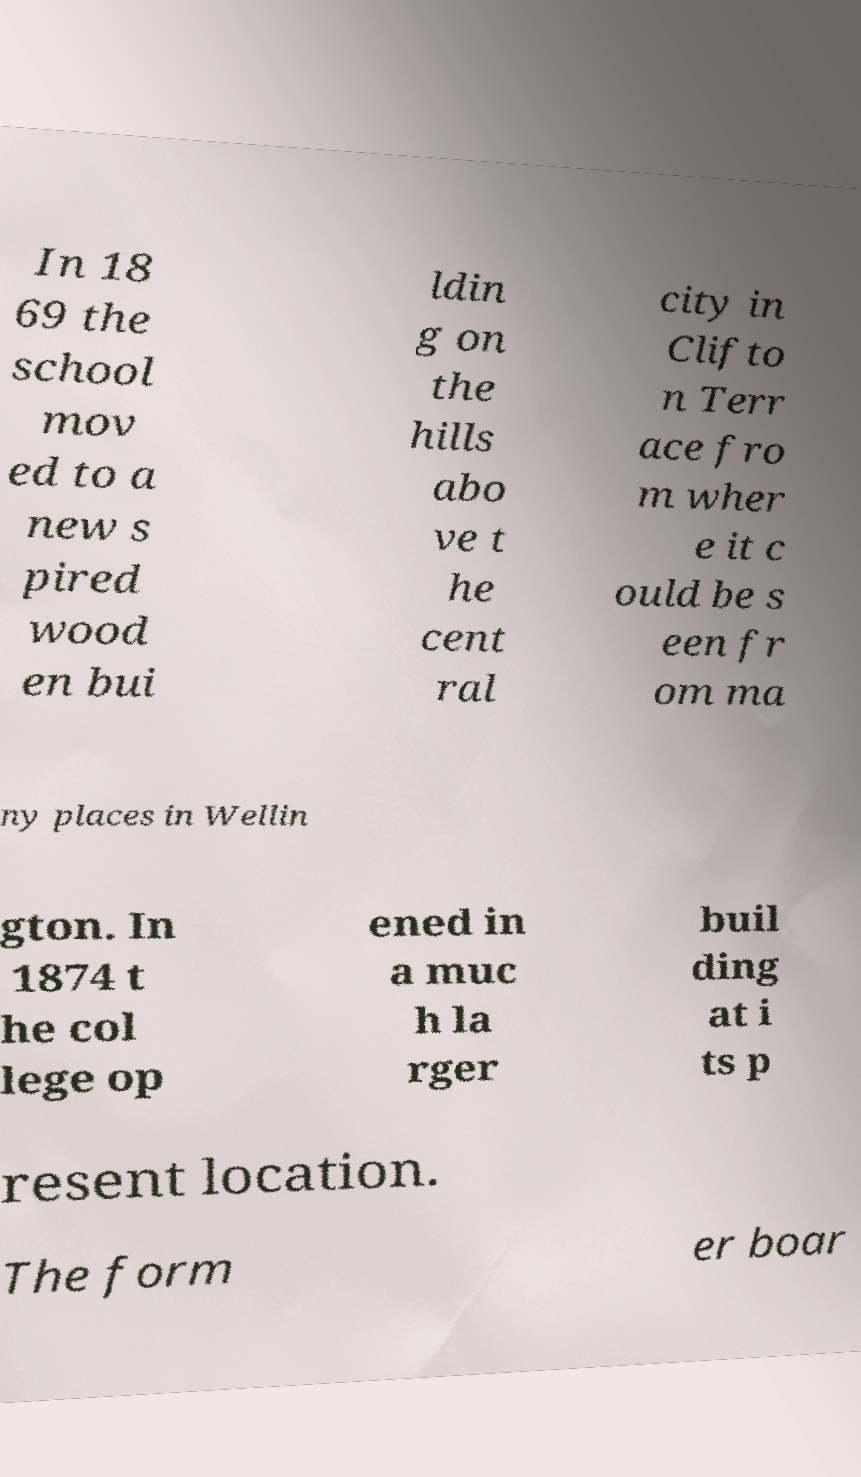Can you read and provide the text displayed in the image?This photo seems to have some interesting text. Can you extract and type it out for me? In 18 69 the school mov ed to a new s pired wood en bui ldin g on the hills abo ve t he cent ral city in Clifto n Terr ace fro m wher e it c ould be s een fr om ma ny places in Wellin gton. In 1874 t he col lege op ened in a muc h la rger buil ding at i ts p resent location. The form er boar 